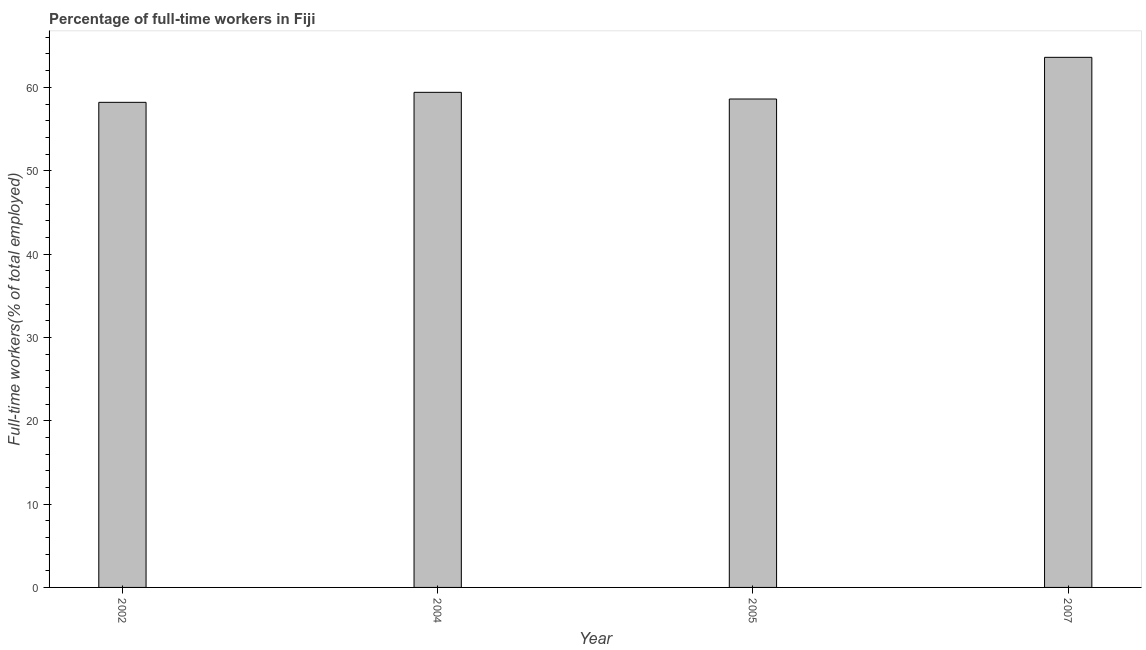What is the title of the graph?
Give a very brief answer. Percentage of full-time workers in Fiji. What is the label or title of the X-axis?
Offer a terse response. Year. What is the label or title of the Y-axis?
Offer a terse response. Full-time workers(% of total employed). What is the percentage of full-time workers in 2002?
Make the answer very short. 58.2. Across all years, what is the maximum percentage of full-time workers?
Provide a short and direct response. 63.6. Across all years, what is the minimum percentage of full-time workers?
Keep it short and to the point. 58.2. What is the sum of the percentage of full-time workers?
Keep it short and to the point. 239.8. What is the average percentage of full-time workers per year?
Make the answer very short. 59.95. What is the median percentage of full-time workers?
Ensure brevity in your answer.  59. Is the percentage of full-time workers in 2005 less than that in 2007?
Make the answer very short. Yes. What is the difference between the highest and the second highest percentage of full-time workers?
Offer a terse response. 4.2. Is the sum of the percentage of full-time workers in 2005 and 2007 greater than the maximum percentage of full-time workers across all years?
Keep it short and to the point. Yes. What is the difference between the highest and the lowest percentage of full-time workers?
Your response must be concise. 5.4. In how many years, is the percentage of full-time workers greater than the average percentage of full-time workers taken over all years?
Give a very brief answer. 1. What is the difference between two consecutive major ticks on the Y-axis?
Provide a short and direct response. 10. What is the Full-time workers(% of total employed) in 2002?
Your response must be concise. 58.2. What is the Full-time workers(% of total employed) in 2004?
Provide a succinct answer. 59.4. What is the Full-time workers(% of total employed) in 2005?
Offer a terse response. 58.6. What is the Full-time workers(% of total employed) of 2007?
Give a very brief answer. 63.6. What is the difference between the Full-time workers(% of total employed) in 2002 and 2007?
Provide a succinct answer. -5.4. What is the difference between the Full-time workers(% of total employed) in 2005 and 2007?
Offer a terse response. -5. What is the ratio of the Full-time workers(% of total employed) in 2002 to that in 2007?
Make the answer very short. 0.92. What is the ratio of the Full-time workers(% of total employed) in 2004 to that in 2007?
Ensure brevity in your answer.  0.93. What is the ratio of the Full-time workers(% of total employed) in 2005 to that in 2007?
Your answer should be compact. 0.92. 